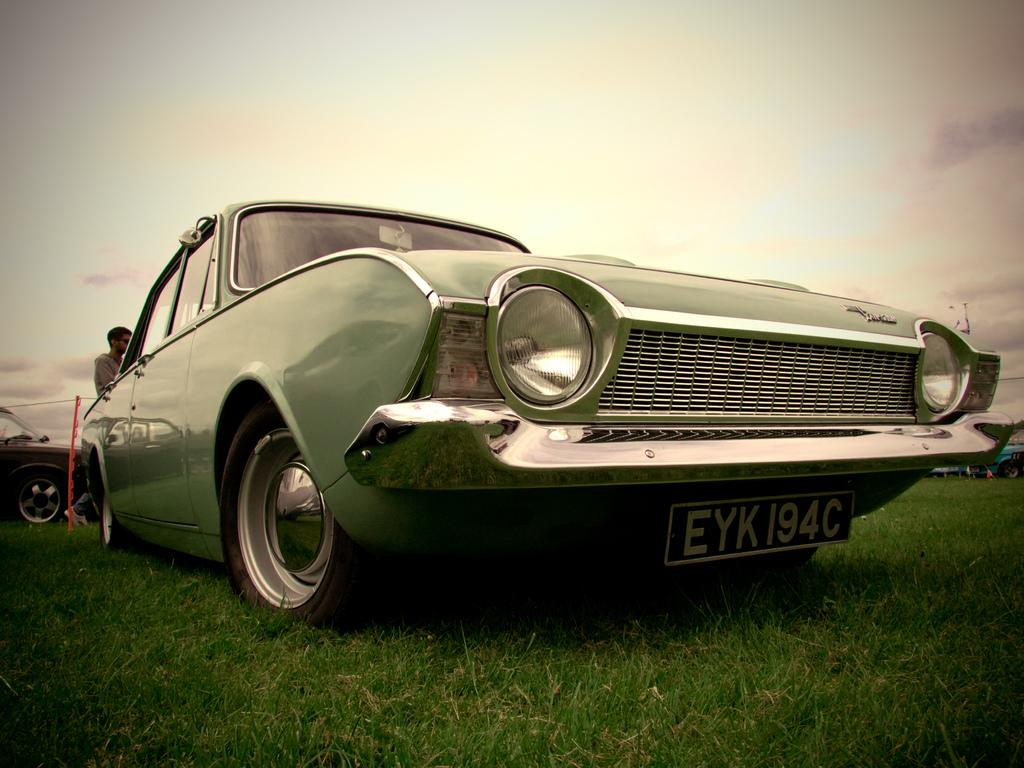Where is the car parked in the image? The car is parked on the grass in the image. Can you describe any other vehicles in the image? Yes, there is another car visible in the background. Are there any people present in the image? Yes, there is a person in the background. What can be seen in the sky in the image? The sky is visible with clouds in the image. What type of table is being used to grow the cabbage in the image? There is no table or cabbage present in the image. What type of crime is being committed in the image? There is no crime or criminal activity depicted in the image. 